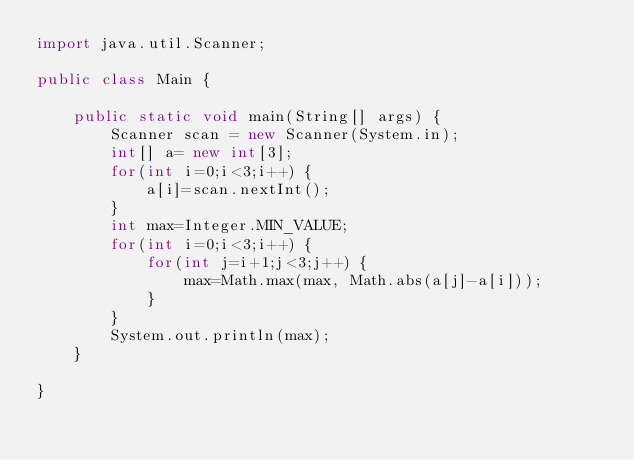<code> <loc_0><loc_0><loc_500><loc_500><_Java_>import java.util.Scanner;

public class Main {

	public static void main(String[] args) {
		Scanner scan = new Scanner(System.in);
		int[] a= new int[3];
		for(int i=0;i<3;i++) {
			a[i]=scan.nextInt();
		}
		int max=Integer.MIN_VALUE;
		for(int i=0;i<3;i++) {
			for(int j=i+1;j<3;j++) {
				max=Math.max(max, Math.abs(a[j]-a[i]));
			}
		}
		System.out.println(max);
	}

}
</code> 